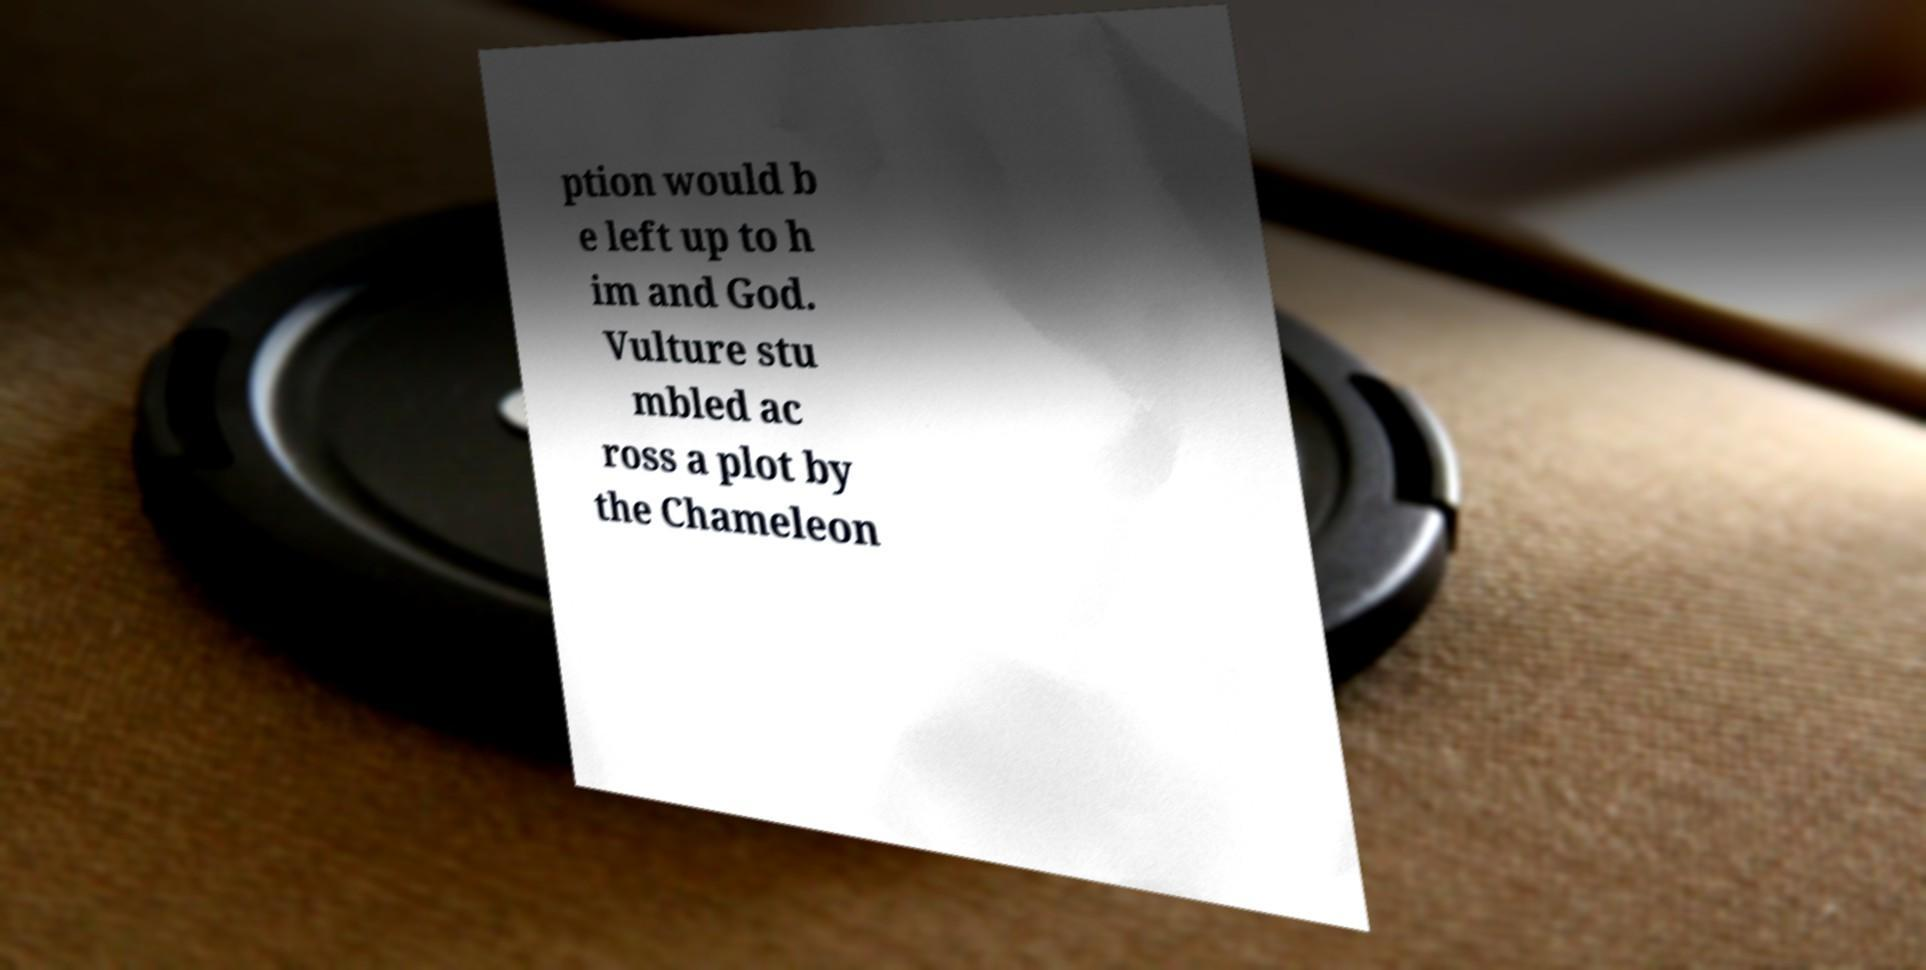Could you assist in decoding the text presented in this image and type it out clearly? ption would b e left up to h im and God. Vulture stu mbled ac ross a plot by the Chameleon 